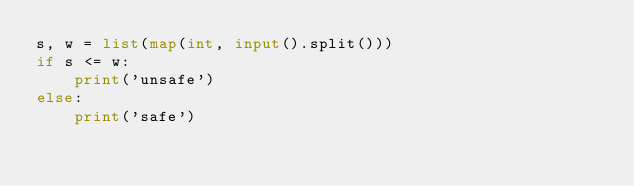Convert code to text. <code><loc_0><loc_0><loc_500><loc_500><_Python_>s, w = list(map(int, input().split()))
if s <= w:
    print('unsafe')
else:
    print('safe')</code> 